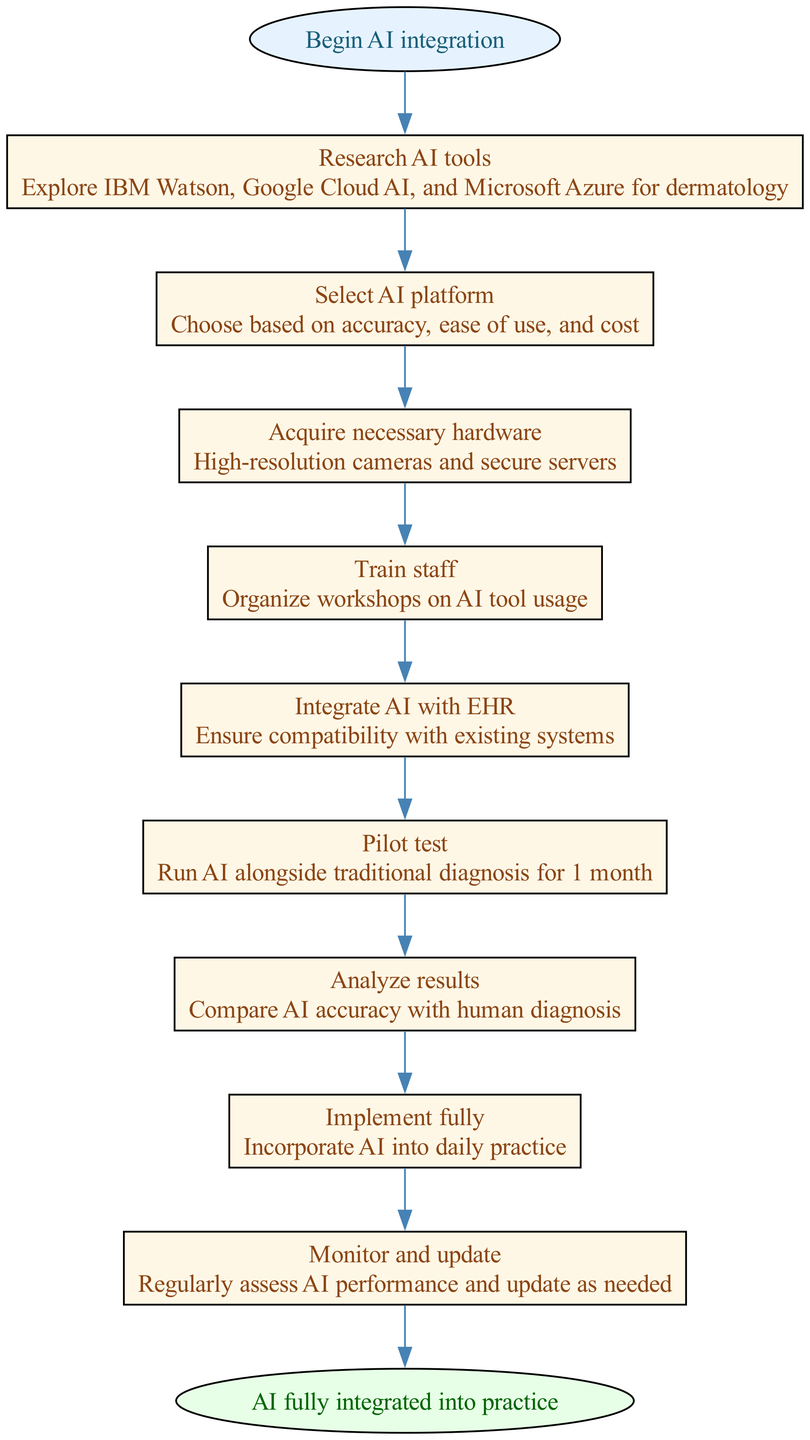What is the first step in the AI integration process? The diagram indicates that the first step is labeled "Begin AI integration," which is the starting point of the flow.
Answer: Begin AI integration How many total steps are in the process? By counting the individual steps listed in the diagram, there are nine steps from "Research AI tools" to "Monitor and update."
Answer: 9 What is the last step in the AI integration flow? The final step noted in the diagram is "AI fully integrated into practice," indicating the completion of the integration process.
Answer: AI fully integrated into practice What is required before integrating AI with EHR? According to the diagram, before the integration with EHR, one must ensure compatibility with existing systems, as stated in the "Integrate AI with EHR" step.
Answer: Compatibility Which step comes after "Pilot test"? Referring to the flow of the diagram, after "Pilot test," the following step is "Analyze results," highlighting the need to assess the pilot test's outcomes.
Answer: Analyze results What should staff do before the AI tools are implemented? The diagram specifies that staff needs to be trained through organized workshops on AI tool usage before implementation, as shown in the "Train staff" step.
Answer: Organized workshops Which step requires comparing AI and human diagnosis accuracy? The step that mandates comparison of diagnosis accuracy is "Analyze results," where the effectiveness of AI is evaluated against human capabilities.
Answer: Analyze results What type of hardware is necessary to acquire? The diagram lists "High-resolution cameras and secure servers" as the necessary hardware in the "Acquire necessary hardware" step for facilitating AI integration.
Answer: High-resolution cameras and secure servers How often should AI performance be assessed after implementation? The "Monitor and update" step suggests that AI performance should be assessed regularly, implying an ongoing commitment to maintenance and improvement.
Answer: Regularly 